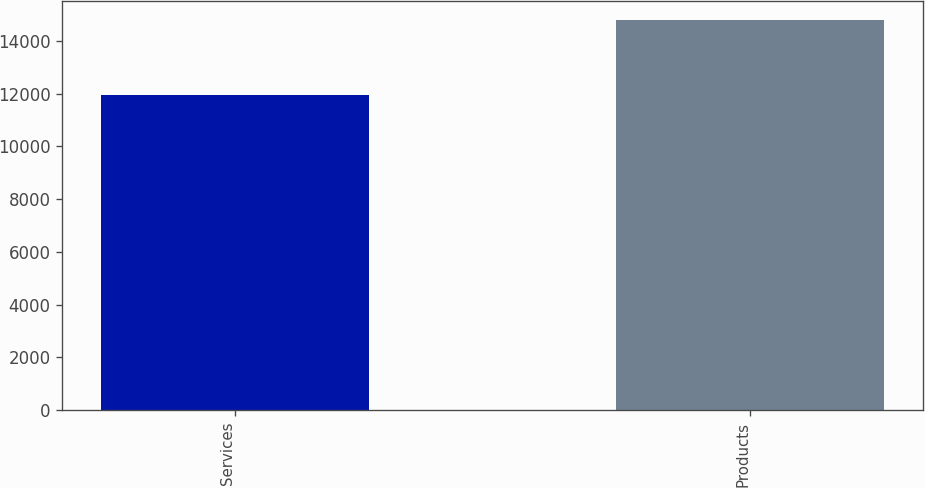<chart> <loc_0><loc_0><loc_500><loc_500><bar_chart><fcel>Services<fcel>Products<nl><fcel>11957<fcel>14799<nl></chart> 